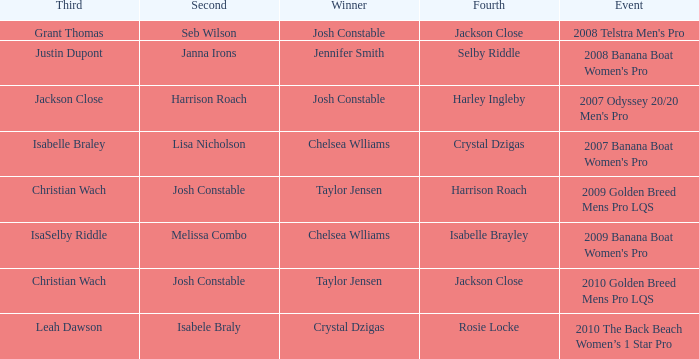Who was in Second Place with Isabelle Brayley came in Fourth? Melissa Combo. 